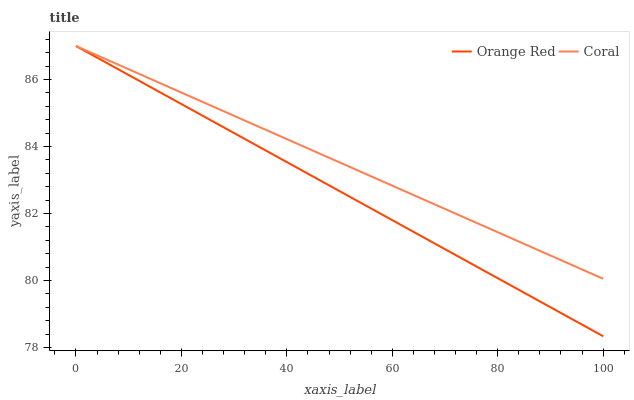Does Orange Red have the minimum area under the curve?
Answer yes or no. Yes. Does Coral have the maximum area under the curve?
Answer yes or no. Yes. Does Orange Red have the maximum area under the curve?
Answer yes or no. No. Is Coral the smoothest?
Answer yes or no. Yes. Is Orange Red the roughest?
Answer yes or no. Yes. 